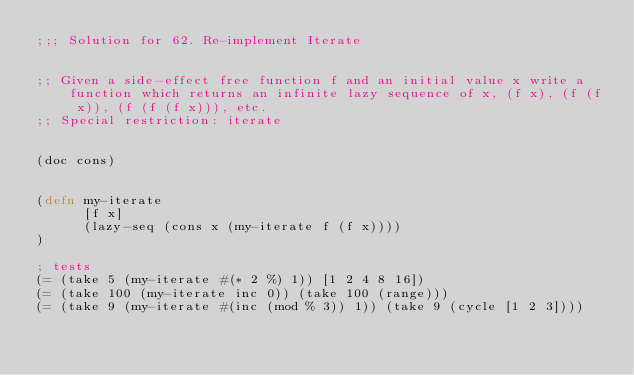Convert code to text. <code><loc_0><loc_0><loc_500><loc_500><_Clojure_>;;; Solution for 62. Re-implement Iterate


;; Given a side-effect free function f and an initial value x write a function which returns an infinite lazy sequence of x, (f x), (f (f x)), (f (f (f x))), etc.
;; Special restriction: iterate


(doc cons)


(defn my-iterate
      [f x]
      (lazy-seq (cons x (my-iterate f (f x))))
)

; tests
(= (take 5 (my-iterate #(* 2 %) 1)) [1 2 4 8 16])
(= (take 100 (my-iterate inc 0)) (take 100 (range)))
(= (take 9 (my-iterate #(inc (mod % 3)) 1)) (take 9 (cycle [1 2 3])))

</code> 